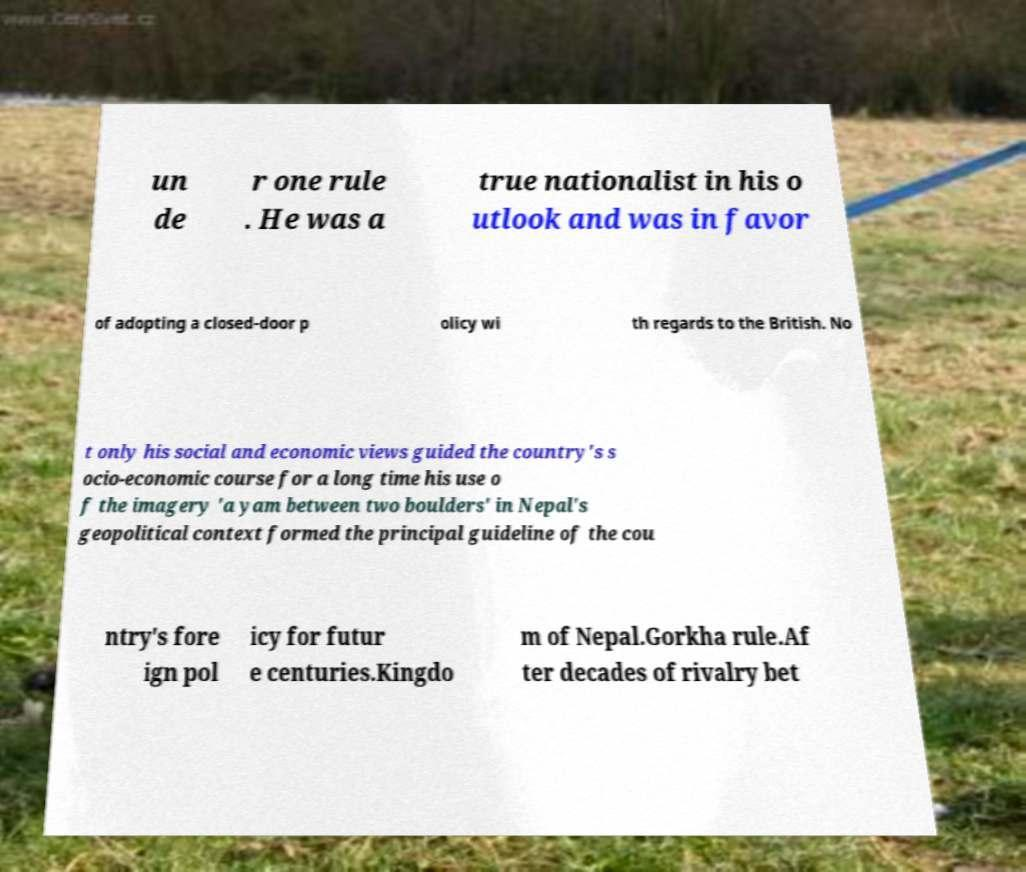Can you accurately transcribe the text from the provided image for me? un de r one rule . He was a true nationalist in his o utlook and was in favor of adopting a closed-door p olicy wi th regards to the British. No t only his social and economic views guided the country's s ocio-economic course for a long time his use o f the imagery 'a yam between two boulders' in Nepal's geopolitical context formed the principal guideline of the cou ntry's fore ign pol icy for futur e centuries.Kingdo m of Nepal.Gorkha rule.Af ter decades of rivalry bet 